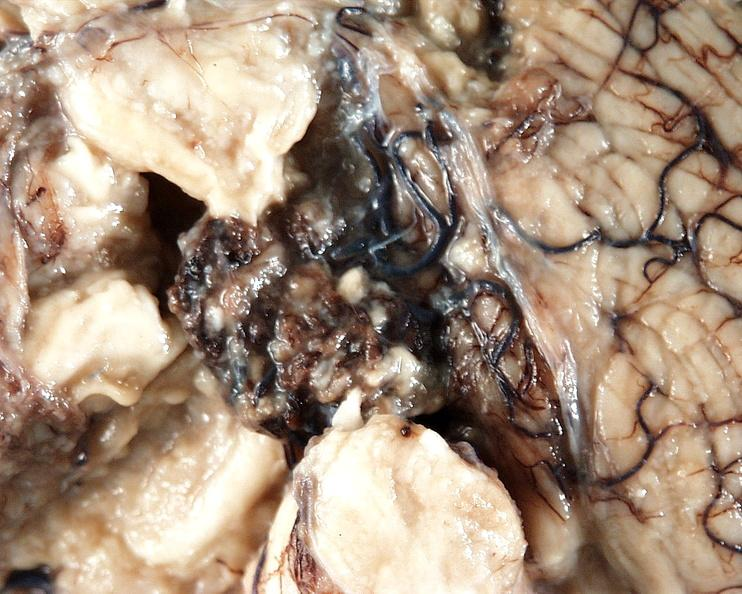what does this image show?
Answer the question using a single word or phrase. Brain 